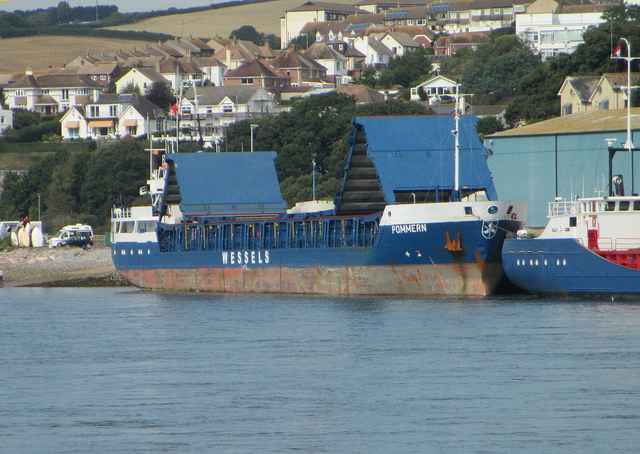Extract all visible text content from this image. WESSELS POMMERAN 